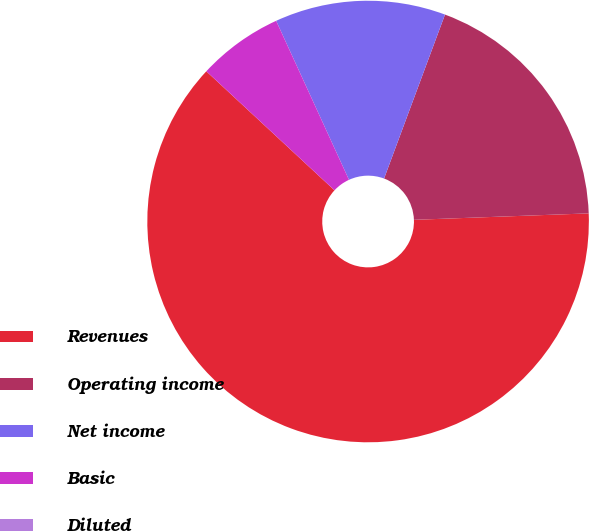Convert chart. <chart><loc_0><loc_0><loc_500><loc_500><pie_chart><fcel>Revenues<fcel>Operating income<fcel>Net income<fcel>Basic<fcel>Diluted<nl><fcel>62.5%<fcel>18.75%<fcel>12.5%<fcel>6.25%<fcel>0.0%<nl></chart> 